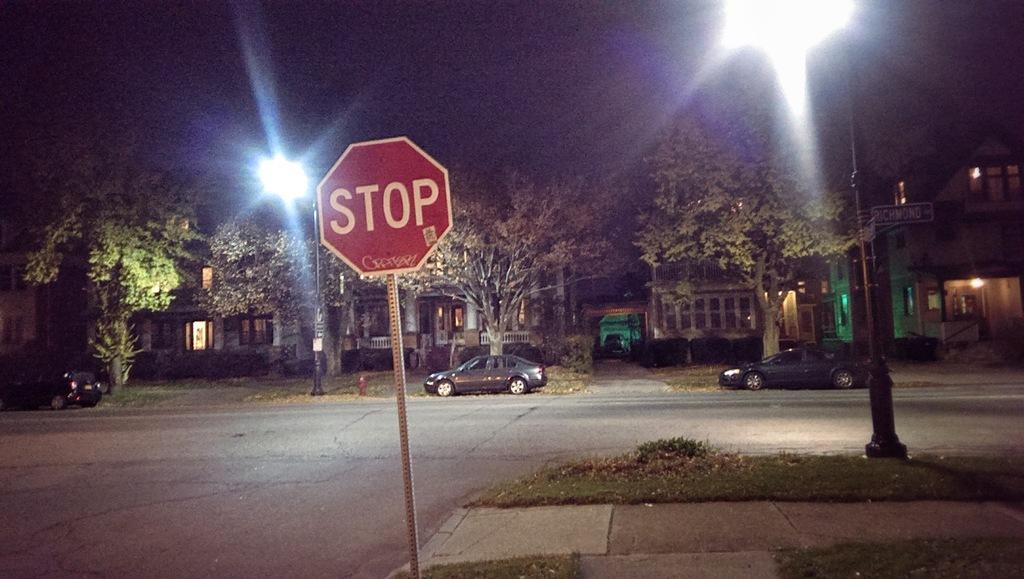What do you need to do at this sign?
Offer a terse response. Stop. 